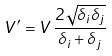<formula> <loc_0><loc_0><loc_500><loc_500>V ^ { \prime } = V \, \frac { 2 \sqrt { \delta _ { i } \delta _ { j } } } { \delta _ { i } + \delta _ { j } }</formula> 